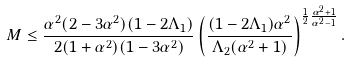<formula> <loc_0><loc_0><loc_500><loc_500>M \leq \frac { \alpha ^ { 2 } ( 2 - 3 \alpha ^ { 2 } ) ( 1 - 2 \Lambda _ { 1 } ) } { 2 ( 1 + \alpha ^ { 2 } ) ( 1 - 3 \alpha ^ { 2 } ) } \left ( \frac { ( 1 - 2 \Lambda _ { 1 } ) \alpha ^ { 2 } } { \Lambda _ { 2 } ( \alpha ^ { 2 } + 1 ) } \right ) ^ { \frac { 1 } { 2 } \frac { \alpha ^ { 2 } + 1 } { \alpha ^ { 2 } - 1 } } .</formula> 